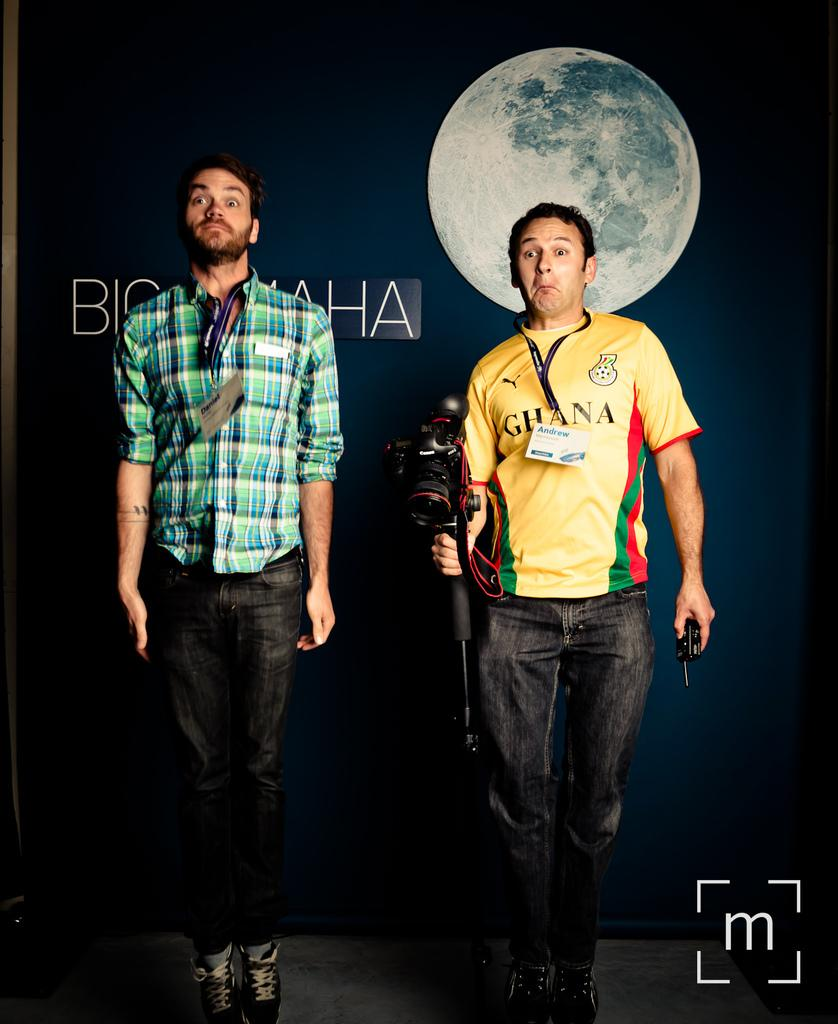<image>
Describe the image concisely. Man wearing a yellow Ghana shirt holding a camera. 